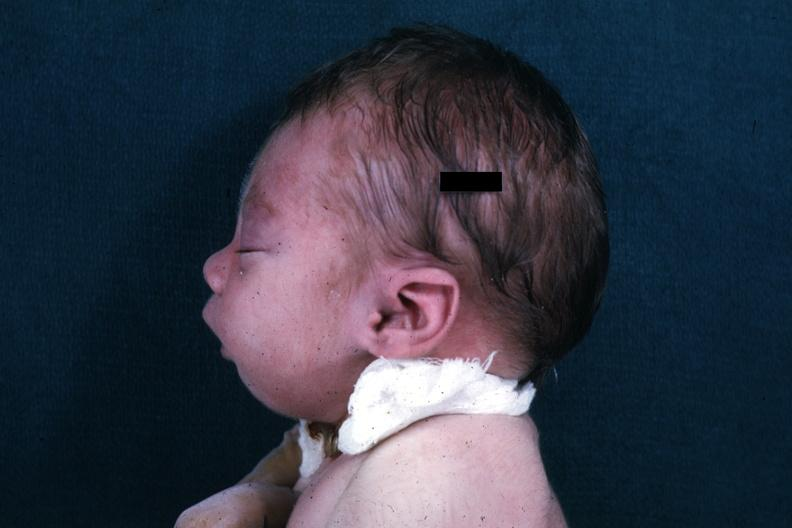how do lateral view of infants head showing lesion?
Answer the question using a single word or phrase. Mandibular 